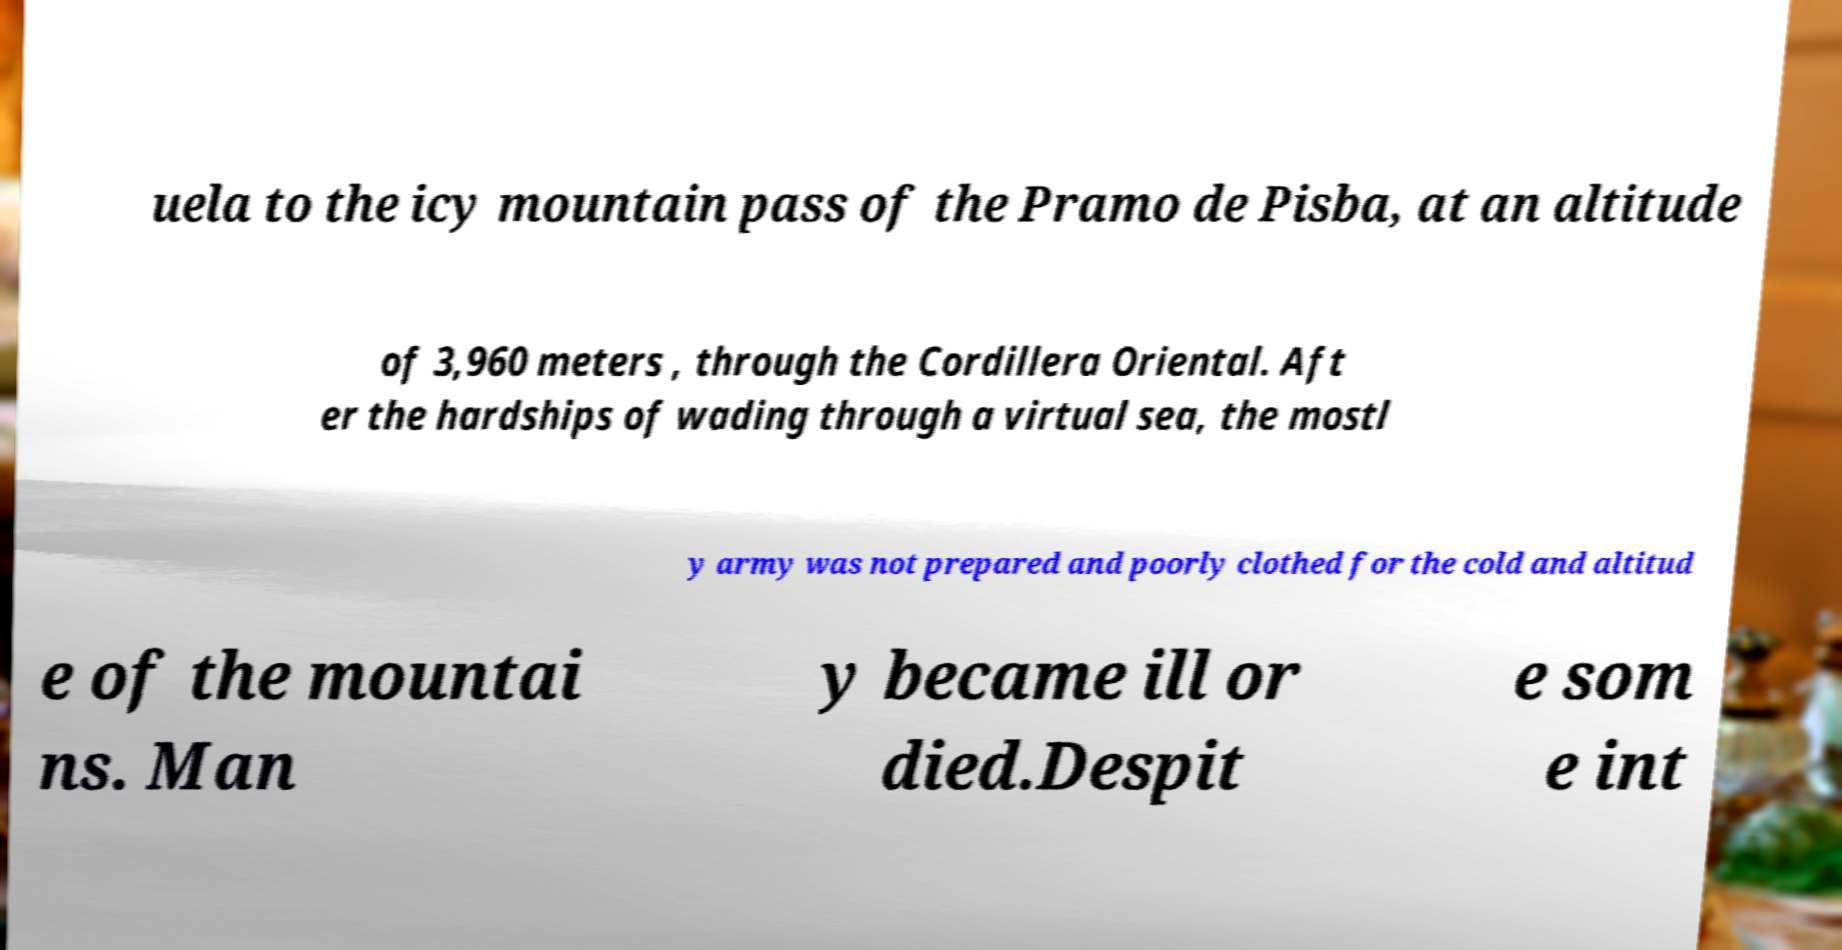Could you assist in decoding the text presented in this image and type it out clearly? uela to the icy mountain pass of the Pramo de Pisba, at an altitude of 3,960 meters , through the Cordillera Oriental. Aft er the hardships of wading through a virtual sea, the mostl y army was not prepared and poorly clothed for the cold and altitud e of the mountai ns. Man y became ill or died.Despit e som e int 